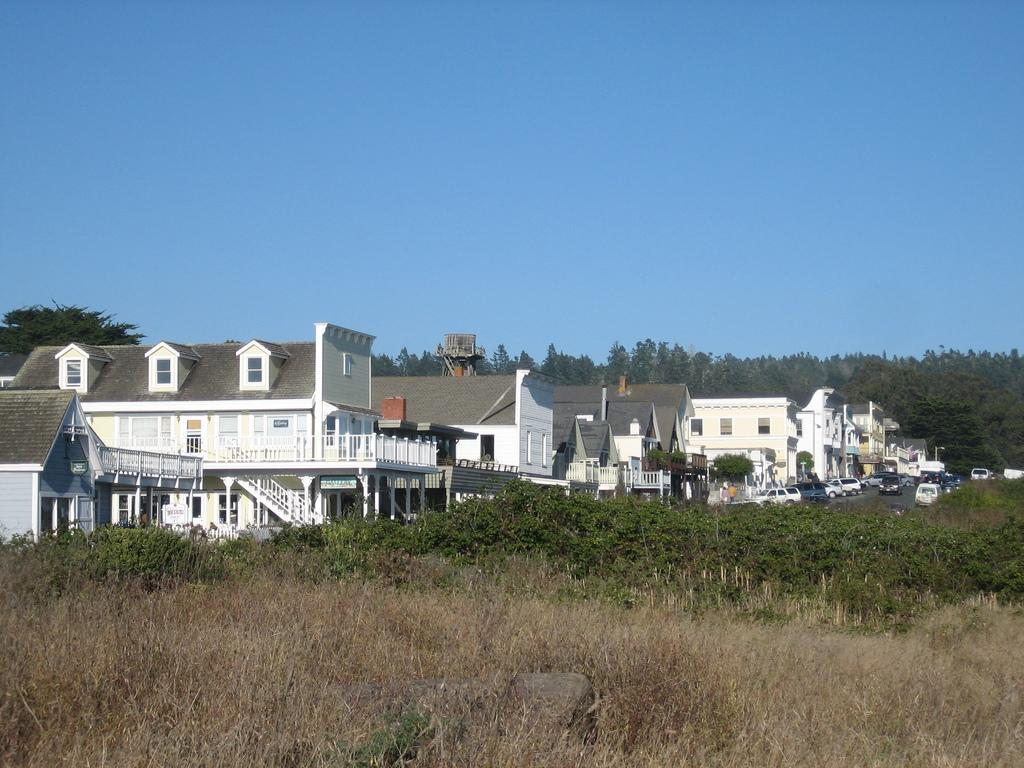What type of natural elements are present in the image? There are many trees and plants in the image. What type of man-made structures are present in the image? There are many houses in the image. What type of transportation is present in the image? There are many vehicles in the image. What part of the natural environment is visible in the image? The sky is visible in the image. What type of chin can be seen on the trees in the image? There are no chins present in the image, as it features trees and plants, houses, vehicles, and the sky. What type of drink is being served in the image? There is no drink present in the image; it features trees and plants, houses, vehicles, and the sky. 